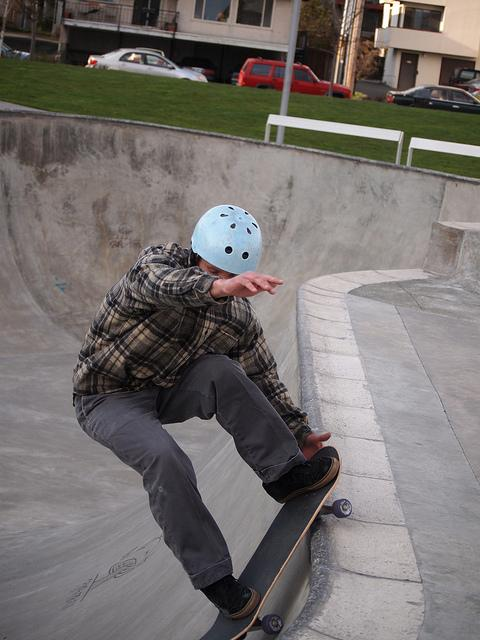Which group allegedly invented skateboards? surfers 